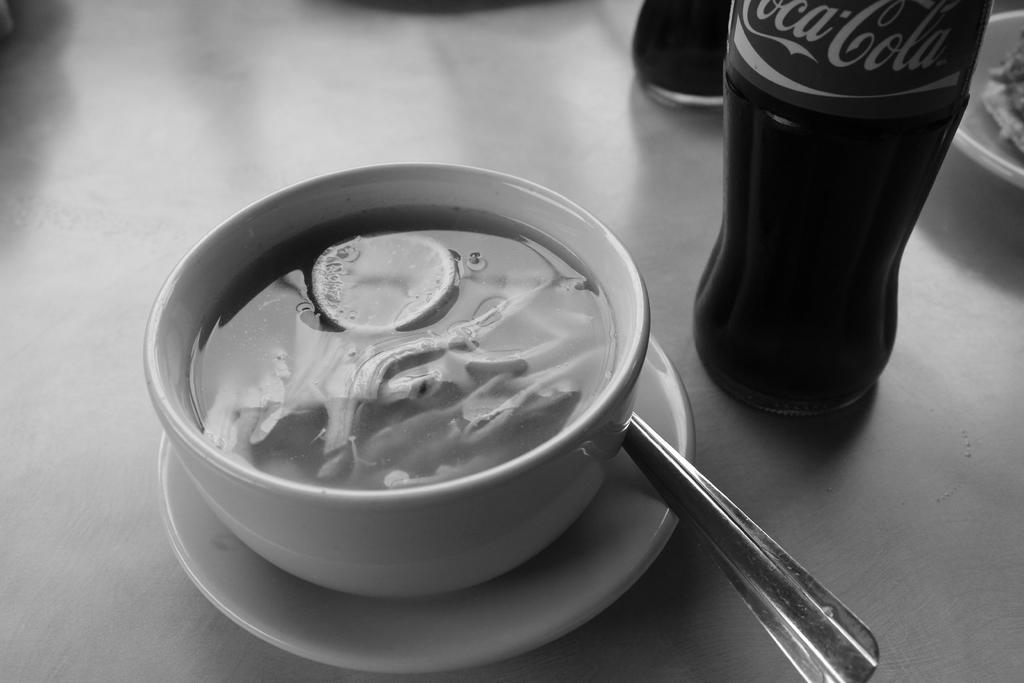<image>
Summarize the visual content of the image. A bottle of Coca-Cola is next to a white bowl filled with a thick creamy looking soup. 